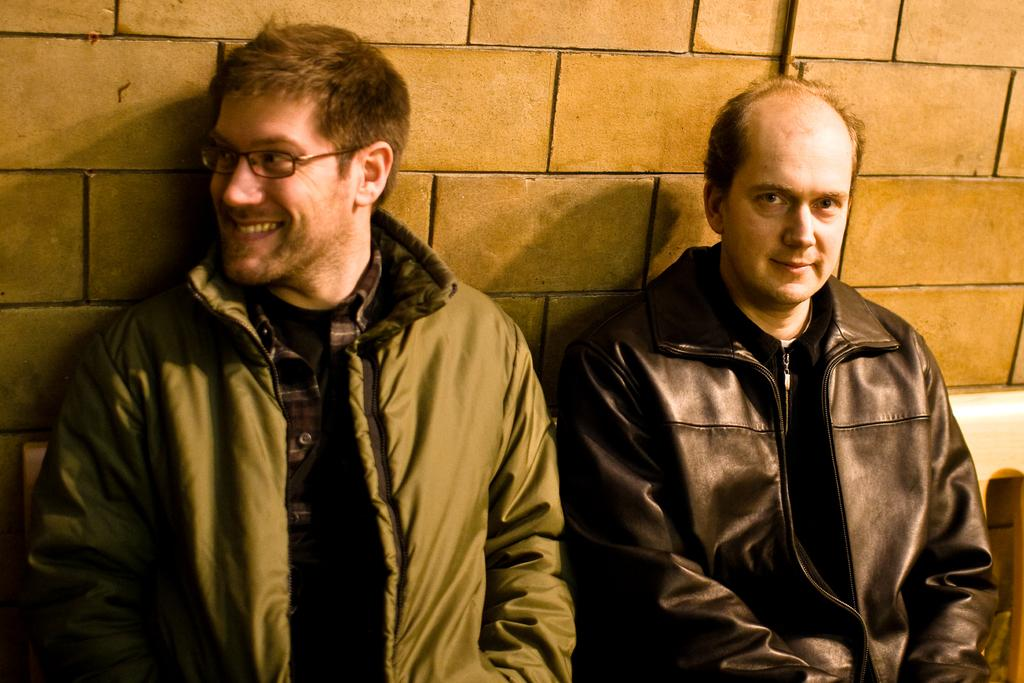How many people are in the image? There are two men in the image. Where are the men located in the image? The men are in the center of the image. What can be seen in the background of the image? There is a wall in the background of the image. What type of jam is being spread on the wall by the stranger in the image? There is no jam or stranger present in the image; it features two men in the center with a wall in the background. 